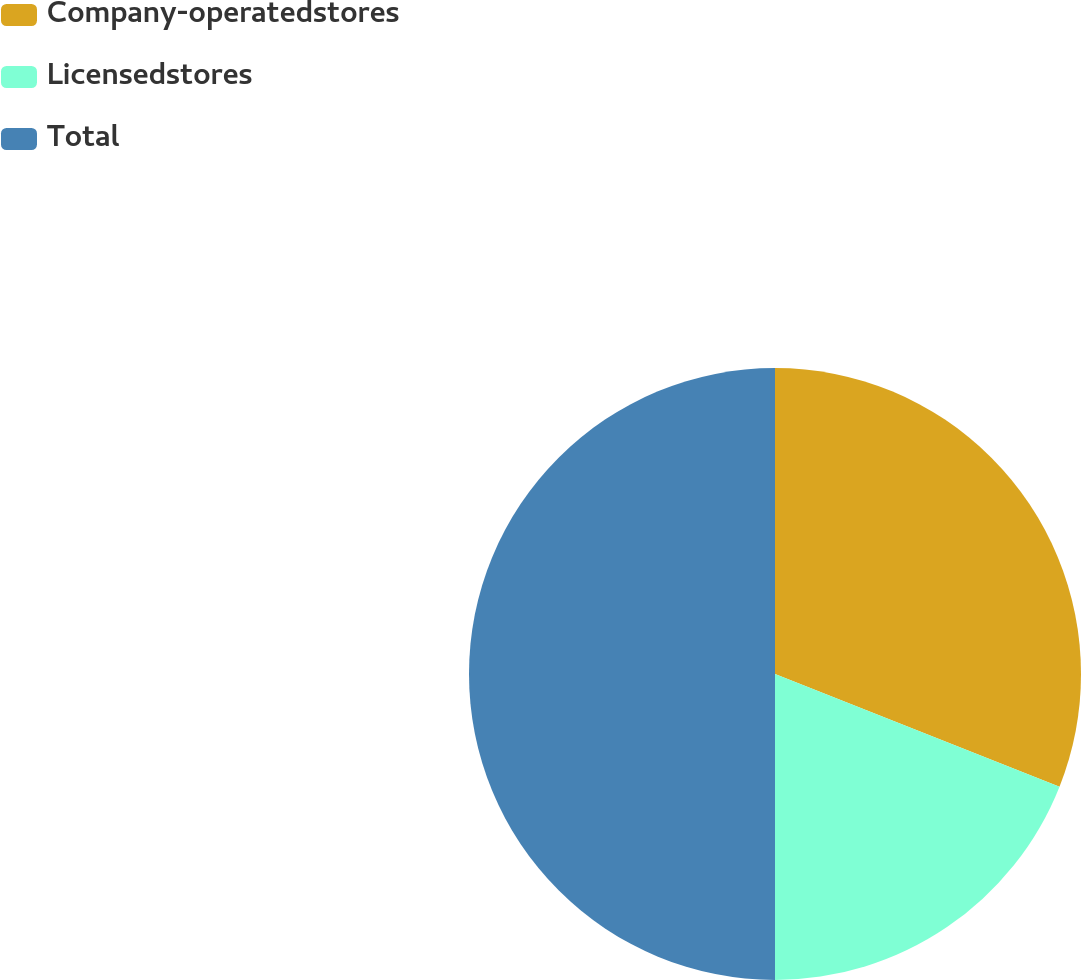Convert chart to OTSL. <chart><loc_0><loc_0><loc_500><loc_500><pie_chart><fcel>Company-operatedstores<fcel>Licensedstores<fcel>Total<nl><fcel>31.0%<fcel>19.0%<fcel>50.0%<nl></chart> 